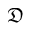<formula> <loc_0><loc_0><loc_500><loc_500>\mathfrak { D }</formula> 